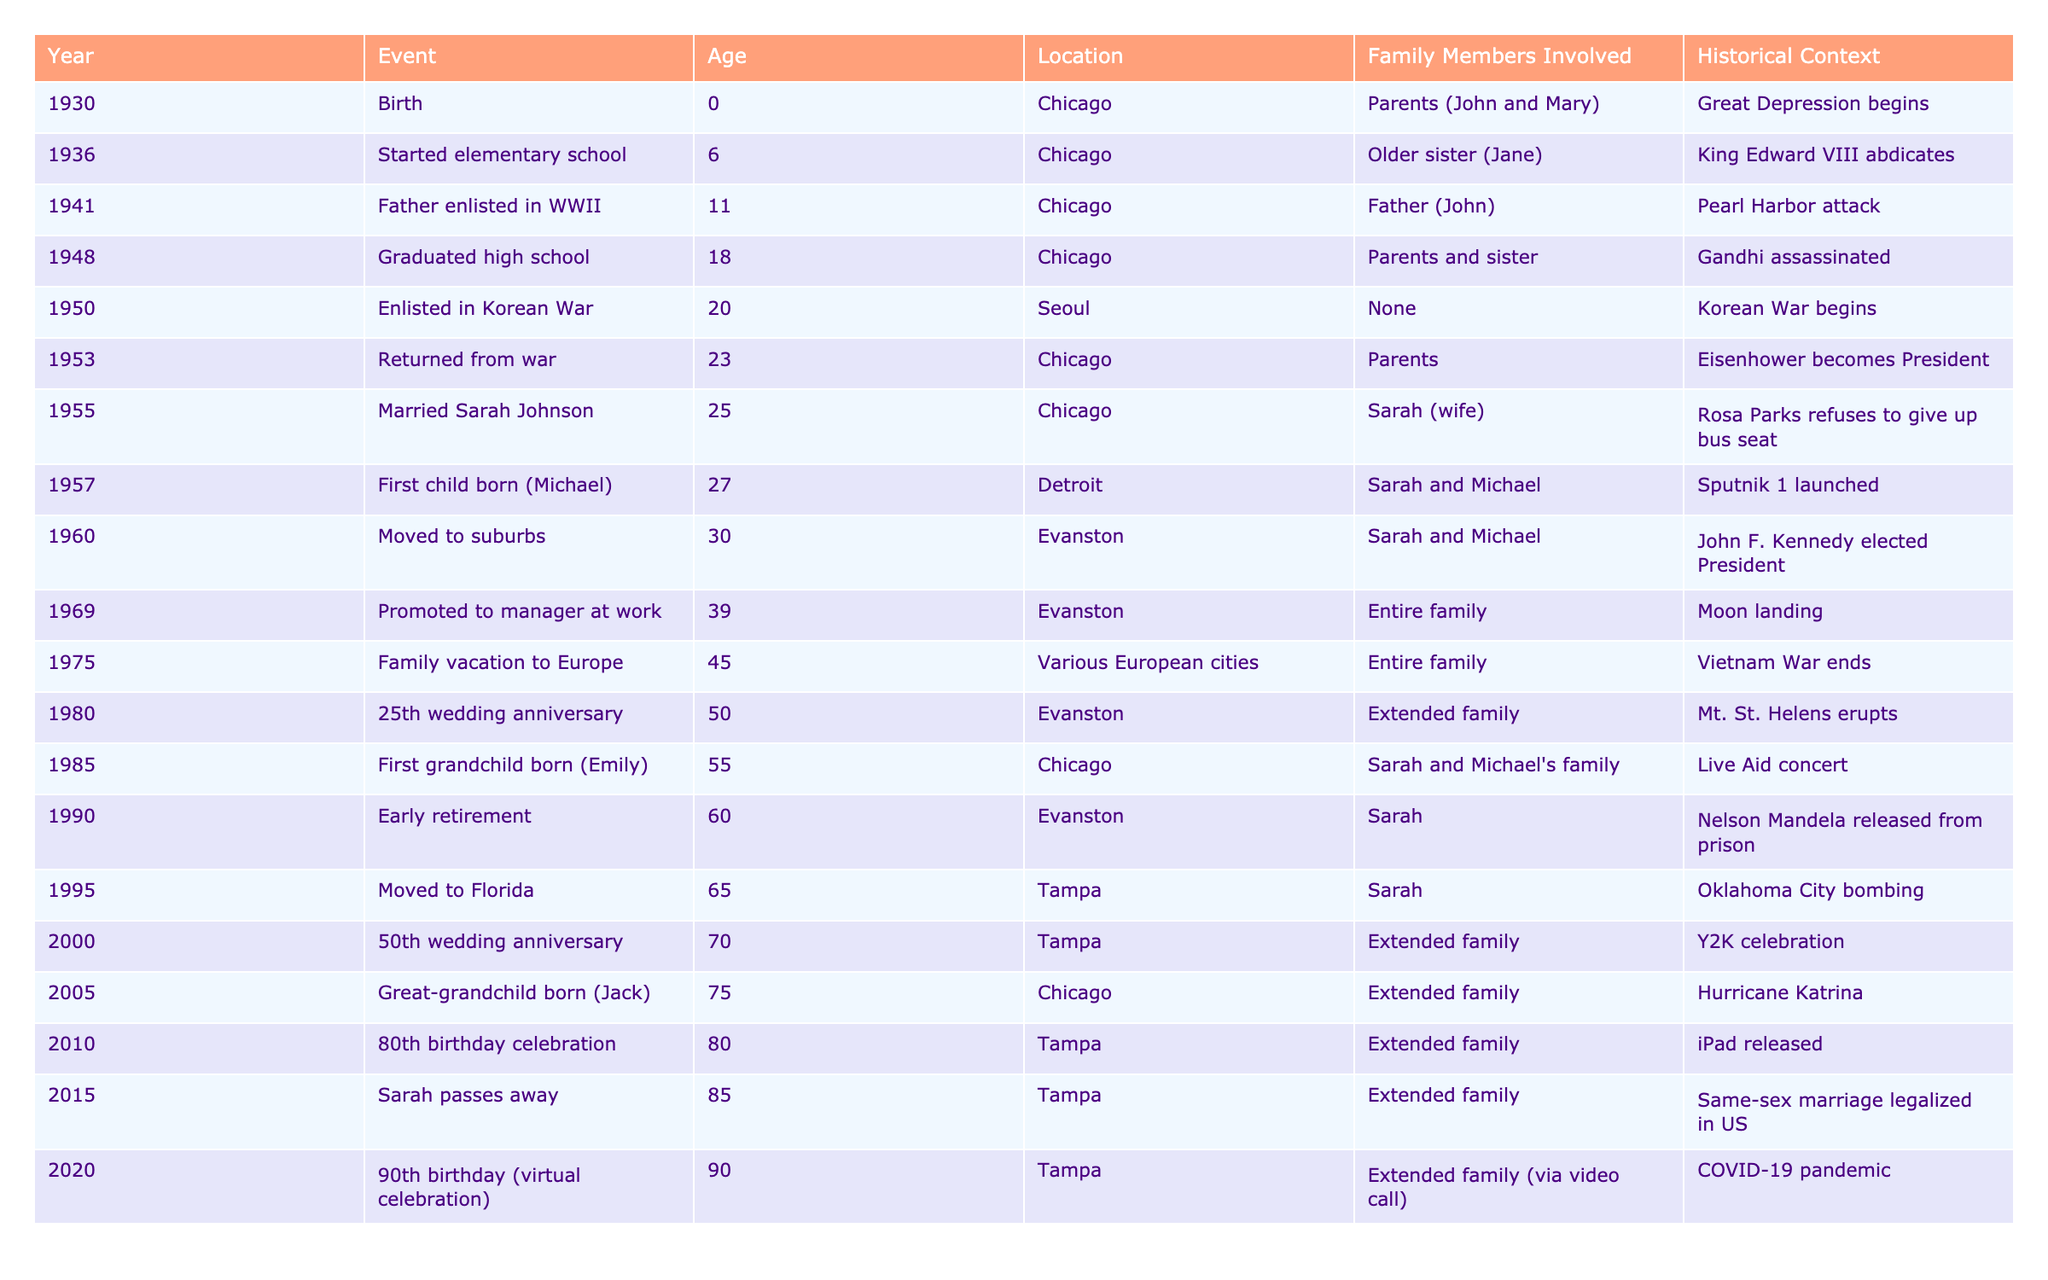What year did your grandparent get married? Referring to the table, the event "Married Sarah Johnson" occurred in the year 1955.
Answer: 1955 How old was your grandparent when their first child was born? The table indicates the event "First child born (Michael)" occurred in 1957 when your grandparent was 27 years old.
Answer: 27 In which city did your grandparent celebrate their 50th wedding anniversary? The table shows that the 50th wedding anniversary event took place in Tampa in the year 2000.
Answer: Tampa True or False: Your grandparent was in school during World War II. According to the events listed, your grandparent started elementary school in 1936 and continued until at least 1948 when they graduated high school, which means they were in school during World War II (1941-1945).
Answer: True What was the age of your grandparent when they first retired? The table specifies the "Early retirement" event happened in 1990, when your grandparent was 60 years old.
Answer: 60 Calculate the age of your grandparent at the time of their first grandchild's birth. The first grandchild, Emily, was born in 1985 and your grandparent was born in 1930. Therefore, their age at that time was 1985 - 1930 = 55 years.
Answer: 55 When did your grandparent move to Florida? The table shows your grandparent moved to Florida in 1995.
Answer: 1995 List all the major events that occurred during your grandparent's life in Chicago. Referring to the table, events in Chicago include Birth (1930), Started elementary school (1936), Graduation from high school (1948), Returned from war (1953), Married (1955), First child born (1957), and first grandchild (1985). The years are: 1930, 1936, 1948, 1953, 1955, 1957, 1985.
Answer: 1930, 1936, 1948, 1953, 1955, 1957, 1985 What significant global event coincided with your grandparent’s birth year? The table shows that the Great Depression began in 1930, the year of your grandparent's birth.
Answer: Great Depression begins How many years after your grandparent was married did they go on a family vacation to Europe? Your grandparent married in 1955 and went on a family vacation in 1975, which is 20 years later (1975 - 1955 = 20).
Answer: 20 years 